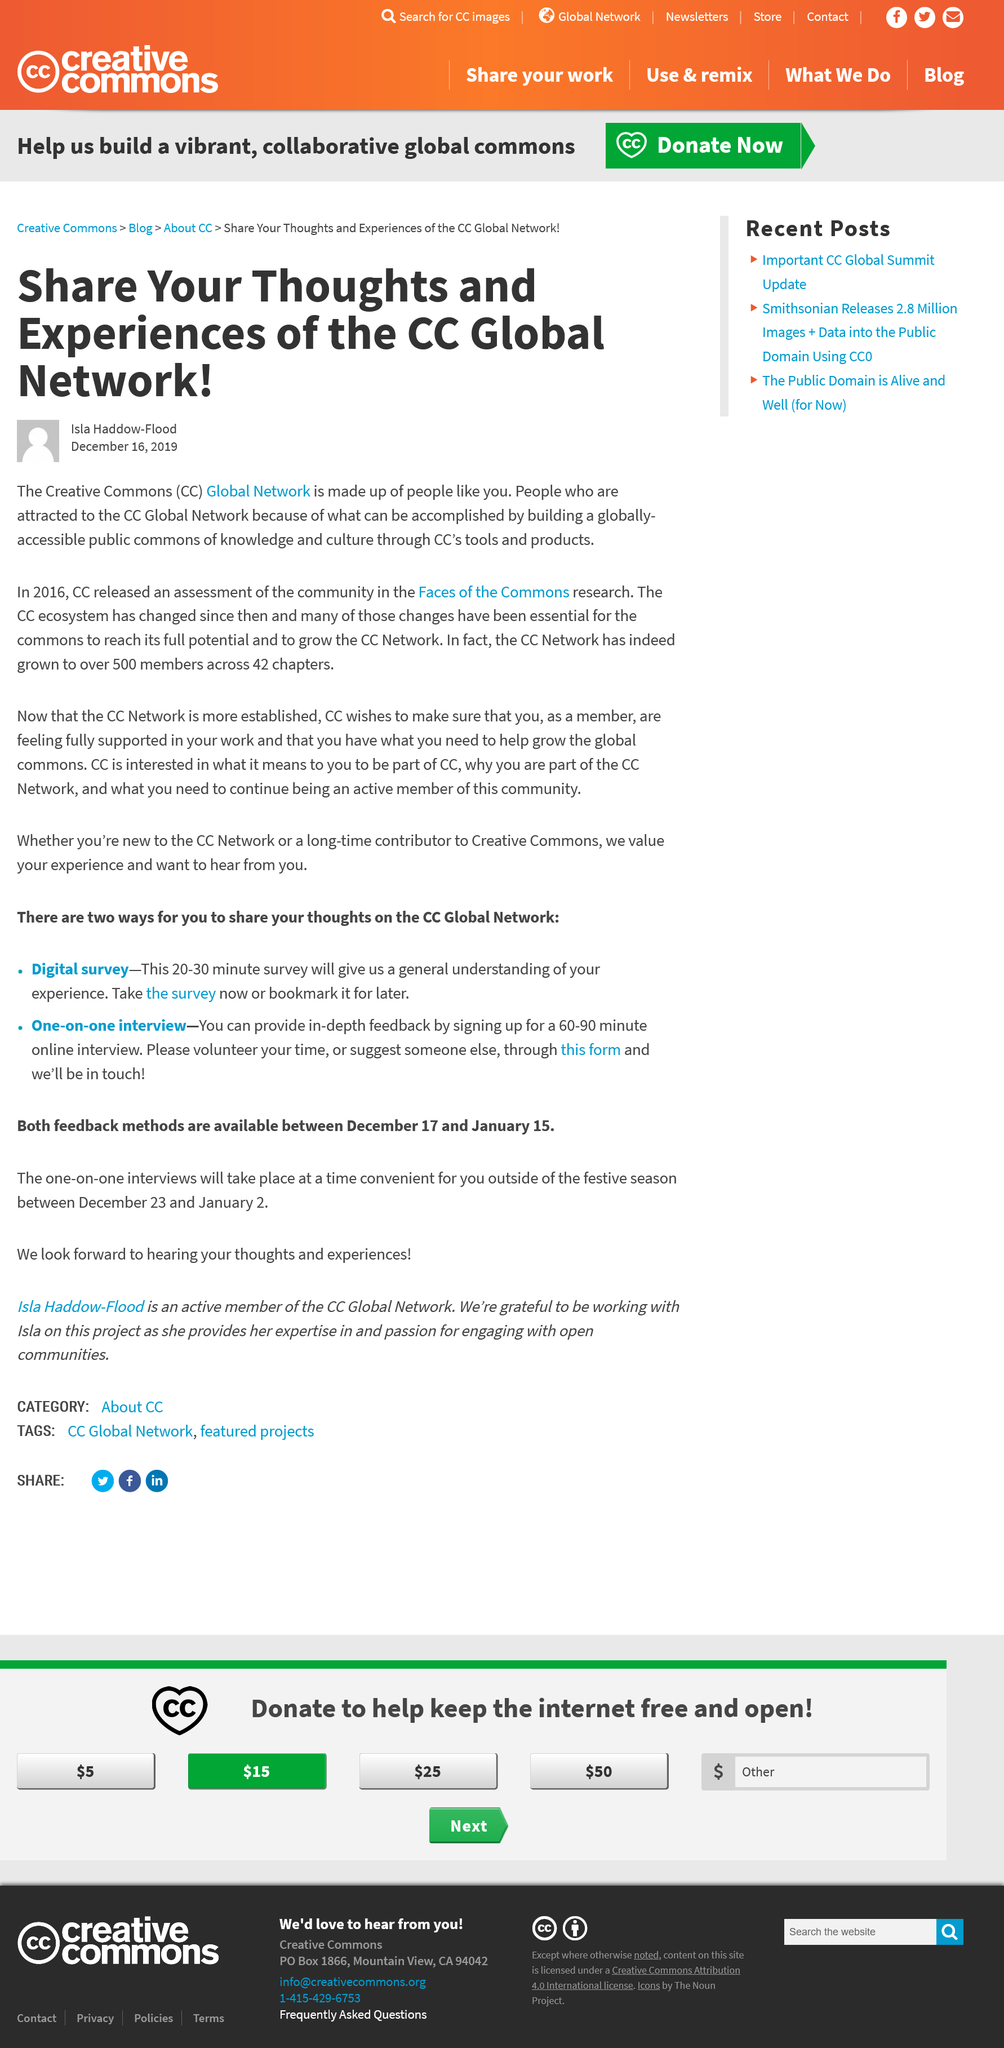Mention a couple of crucial points in this snapshot. The CC Network has 500 members. The CC Network has 42 chapters. Certainly! The release of the assessment by CC took place in 2016. 